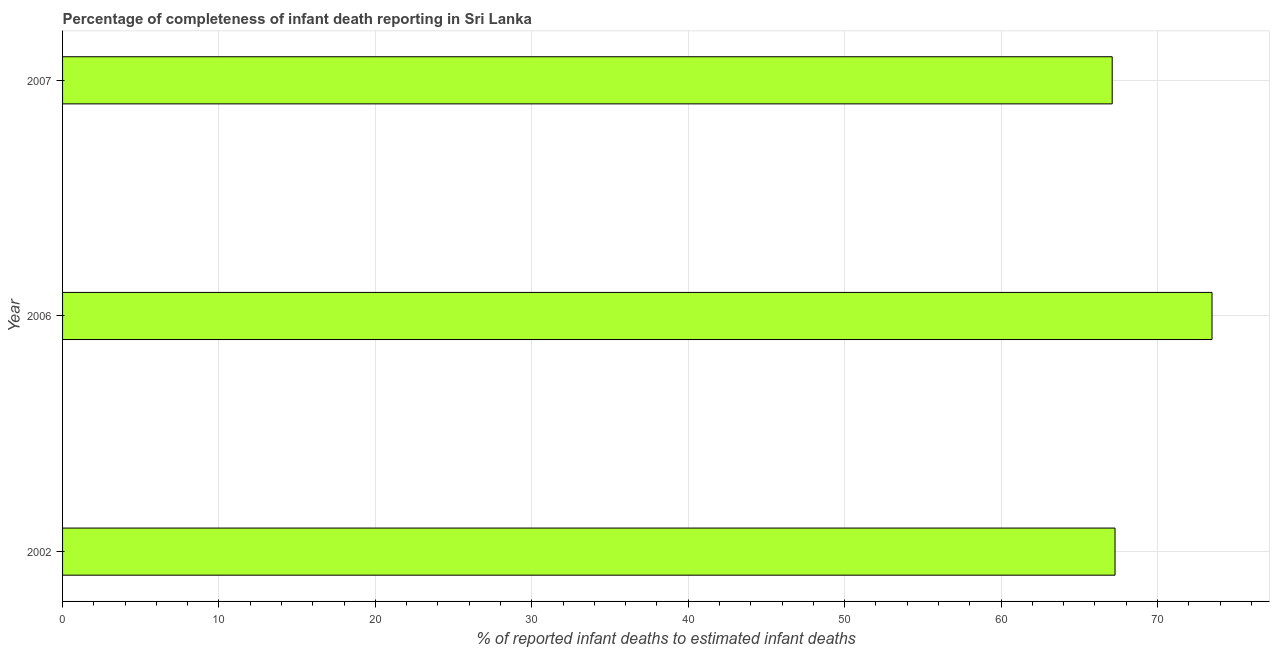Does the graph contain any zero values?
Offer a very short reply. No. Does the graph contain grids?
Keep it short and to the point. Yes. What is the title of the graph?
Your response must be concise. Percentage of completeness of infant death reporting in Sri Lanka. What is the label or title of the X-axis?
Give a very brief answer. % of reported infant deaths to estimated infant deaths. What is the completeness of infant death reporting in 2007?
Offer a very short reply. 67.1. Across all years, what is the maximum completeness of infant death reporting?
Your response must be concise. 73.48. Across all years, what is the minimum completeness of infant death reporting?
Your answer should be very brief. 67.1. What is the sum of the completeness of infant death reporting?
Your answer should be compact. 207.87. What is the difference between the completeness of infant death reporting in 2006 and 2007?
Your answer should be compact. 6.38. What is the average completeness of infant death reporting per year?
Your response must be concise. 69.29. What is the median completeness of infant death reporting?
Offer a terse response. 67.28. Do a majority of the years between 2006 and 2007 (inclusive) have completeness of infant death reporting greater than 10 %?
Provide a short and direct response. Yes. What is the ratio of the completeness of infant death reporting in 2002 to that in 2006?
Give a very brief answer. 0.92. Is the difference between the completeness of infant death reporting in 2006 and 2007 greater than the difference between any two years?
Make the answer very short. Yes. What is the difference between the highest and the second highest completeness of infant death reporting?
Ensure brevity in your answer.  6.2. What is the difference between the highest and the lowest completeness of infant death reporting?
Make the answer very short. 6.38. In how many years, is the completeness of infant death reporting greater than the average completeness of infant death reporting taken over all years?
Make the answer very short. 1. How many bars are there?
Make the answer very short. 3. Are all the bars in the graph horizontal?
Keep it short and to the point. Yes. How many years are there in the graph?
Your answer should be compact. 3. What is the difference between two consecutive major ticks on the X-axis?
Ensure brevity in your answer.  10. Are the values on the major ticks of X-axis written in scientific E-notation?
Ensure brevity in your answer.  No. What is the % of reported infant deaths to estimated infant deaths of 2002?
Provide a succinct answer. 67.28. What is the % of reported infant deaths to estimated infant deaths of 2006?
Make the answer very short. 73.48. What is the % of reported infant deaths to estimated infant deaths of 2007?
Provide a short and direct response. 67.1. What is the difference between the % of reported infant deaths to estimated infant deaths in 2002 and 2006?
Give a very brief answer. -6.2. What is the difference between the % of reported infant deaths to estimated infant deaths in 2002 and 2007?
Offer a terse response. 0.18. What is the difference between the % of reported infant deaths to estimated infant deaths in 2006 and 2007?
Ensure brevity in your answer.  6.38. What is the ratio of the % of reported infant deaths to estimated infant deaths in 2002 to that in 2006?
Offer a very short reply. 0.92. What is the ratio of the % of reported infant deaths to estimated infant deaths in 2006 to that in 2007?
Give a very brief answer. 1.09. 